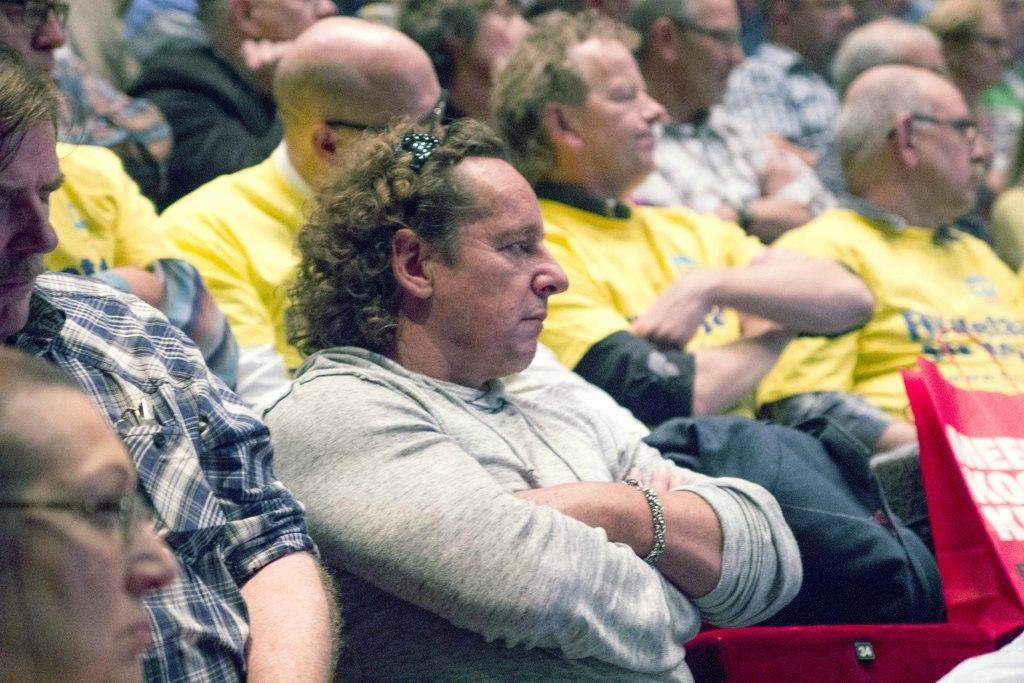What can be seen in the image? There is a group of people in the image. How can you identify some of the people in the group? Four people are wearing yellow t-shirts. Can you describe any specific detail about one of the individuals? One person is wearing spectacles. What is present in the foreground of the image? There is a red bag with some text on it in the foreground. What type of furniture can be seen in the image? There is no furniture present in the image. Can you describe the smell in the image? There is no information about the smell in the image. 